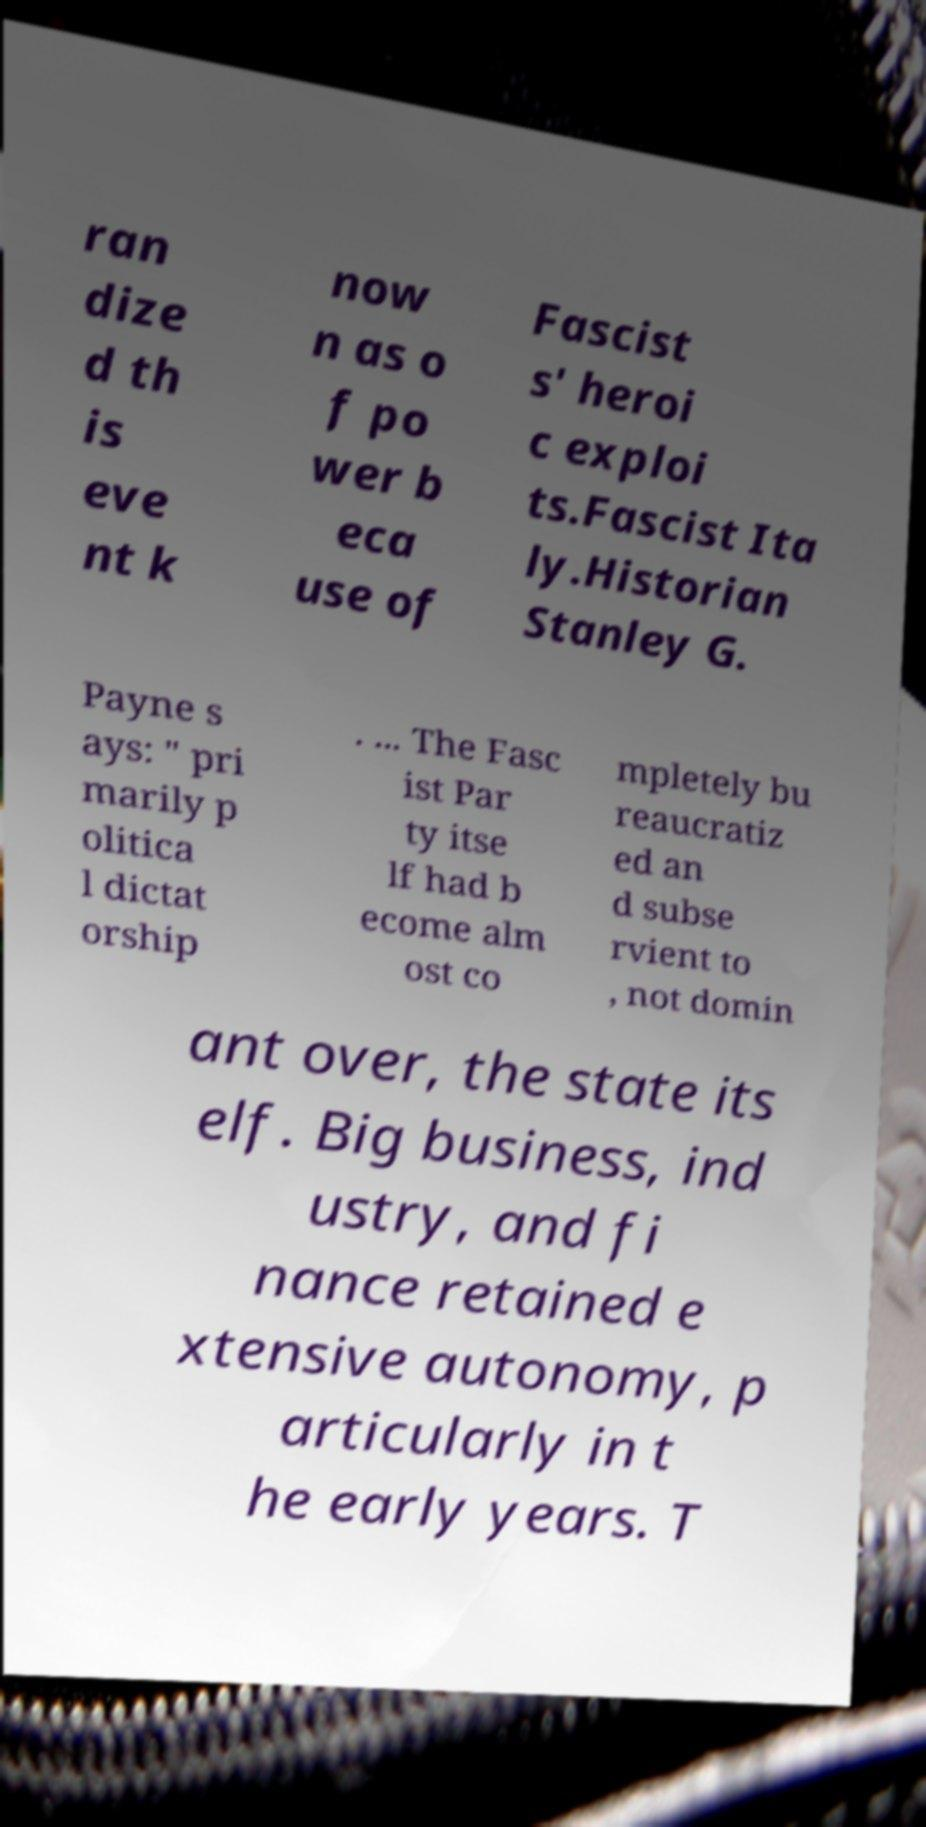Please identify and transcribe the text found in this image. ran dize d th is eve nt k now n as o f po wer b eca use of Fascist s' heroi c exploi ts.Fascist Ita ly.Historian Stanley G. Payne s ays: " pri marily p olitica l dictat orship . ... The Fasc ist Par ty itse lf had b ecome alm ost co mpletely bu reaucratiz ed an d subse rvient to , not domin ant over, the state its elf. Big business, ind ustry, and fi nance retained e xtensive autonomy, p articularly in t he early years. T 